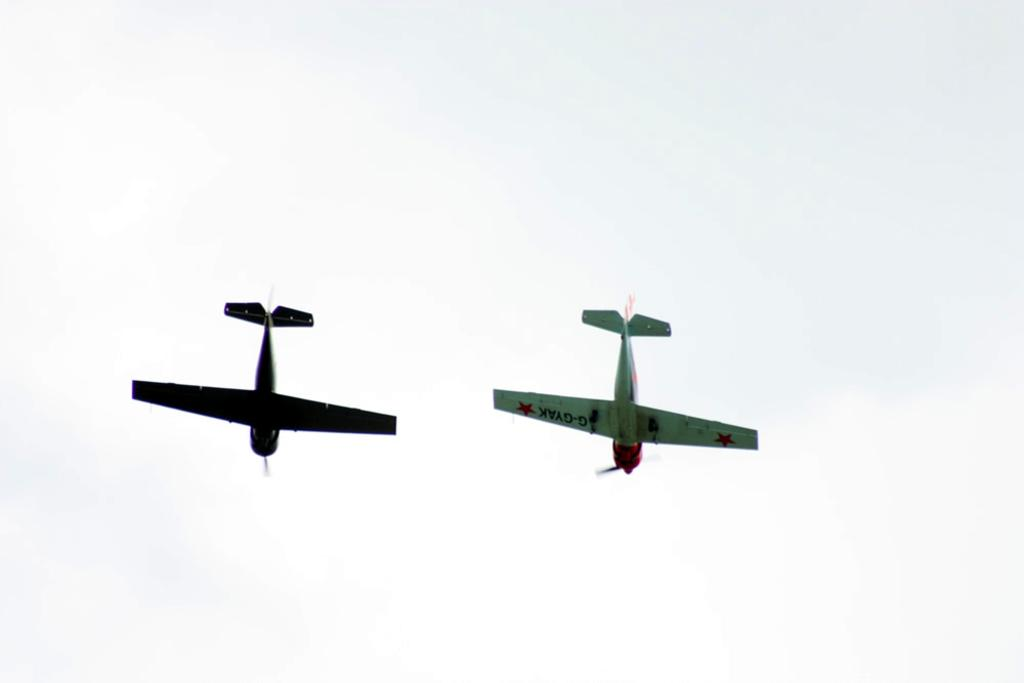How many aeroplanes are in the image? There are two aeroplanes in the image. Where are the aeroplanes located in the image? The aeroplanes are in the air. What is visible in the background of the image? There is a sky visible in the background of the image. Where is the table located in the image? There is no table present in the image. What type of payment method is accepted by the aeroplanes in the image? The image does not depict any payment methods, as it features aeroplanes in the air. Can you see a sink in the image? There is no sink present in the image. 